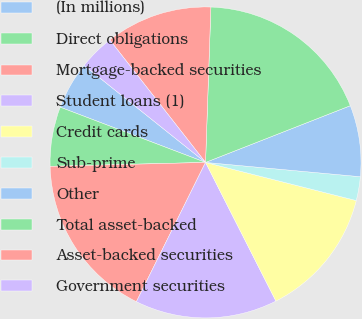<chart> <loc_0><loc_0><loc_500><loc_500><pie_chart><fcel>(In millions)<fcel>Direct obligations<fcel>Mortgage-backed securities<fcel>Student loans (1)<fcel>Credit cards<fcel>Sub-prime<fcel>Other<fcel>Total asset-backed<fcel>Asset-backed securities<fcel>Government securities<nl><fcel>4.95%<fcel>6.18%<fcel>17.27%<fcel>14.81%<fcel>13.58%<fcel>2.48%<fcel>7.41%<fcel>18.51%<fcel>11.11%<fcel>3.71%<nl></chart> 